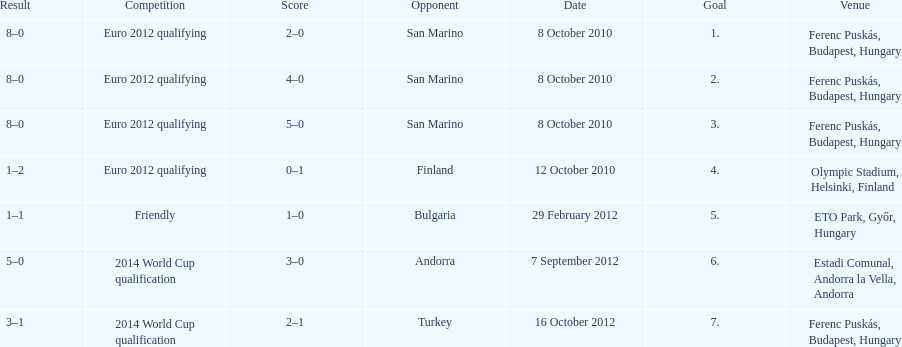When did ádám szalai make his first international goal? 8 October 2010. 